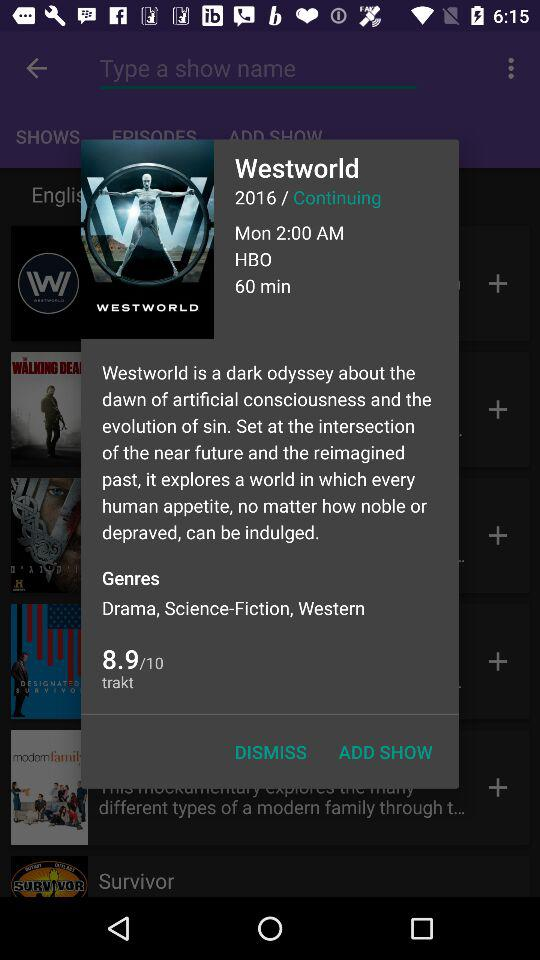What are the genres of the series? The genres of the series are drama, science-fiction, and and western. 